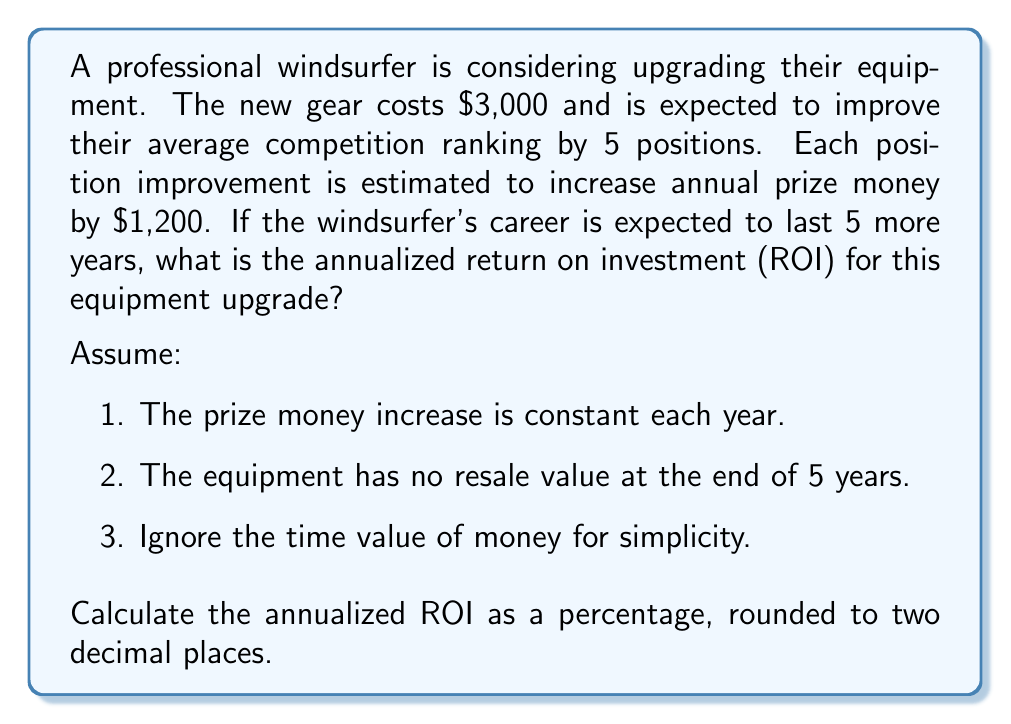Can you solve this math problem? Let's approach this problem step-by-step:

1. Calculate the total additional prize money over 5 years:
   $$ \text{Additional prize money} = 5 \text{ positions} \times \$1,200 \text{ per position} \times 5 \text{ years} = \$30,000 $$

2. Calculate the total profit:
   $$ \text{Profit} = \text{Additional prize money} - \text{Cost of equipment} $$
   $$ \text{Profit} = \$30,000 - \$3,000 = \$27,000 $$

3. Calculate the total ROI over 5 years:
   $$ \text{Total ROI} = \frac{\text{Profit}}{\text{Cost of equipment}} \times 100\% $$
   $$ \text{Total ROI} = \frac{\$27,000}{\$3,000} \times 100\% = 900\% $$

4. To find the annualized ROI, we need to find the rate that, when compounded over 5 years, gives us the total ROI of 900%.

   Let $r$ be the annualized ROI as a decimal. We need to solve:
   $$ (1 + r)^5 = 1 + 9 $$
   $$ (1 + r)^5 = 10 $$
   $$ 1 + r = 10^{\frac{1}{5}} $$
   $$ r = 10^{\frac{1}{5}} - 1 $$
   $$ r \approx 0.5848 \text{ or } 58.48\% $$

Therefore, the annualized ROI is approximately 58.48%.
Answer: 58.48% 